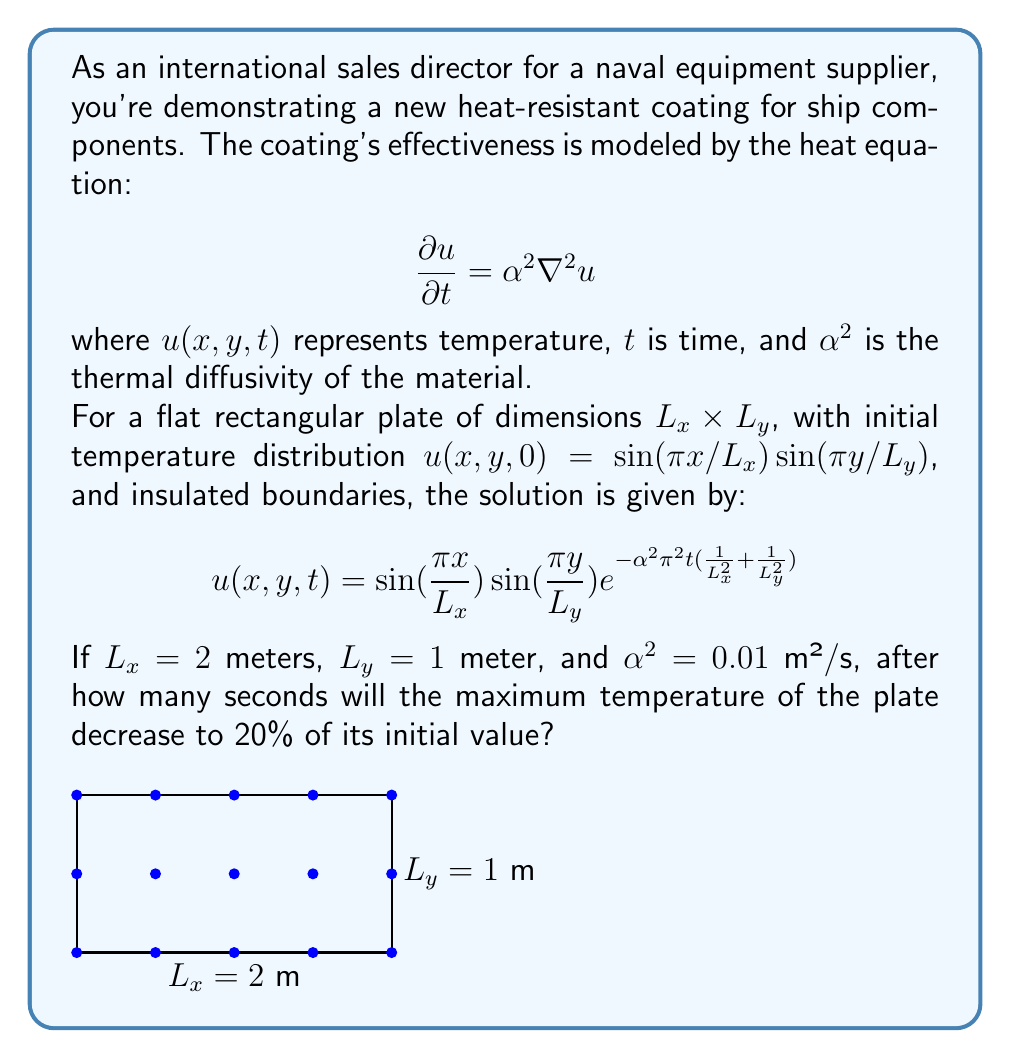Give your solution to this math problem. Let's approach this step-by-step:

1) The maximum temperature occurs at the center of the plate $(L_x/2, L_y/2)$ at any given time. We need to find $t$ when:

   $$u(L_x/2, L_y/2, t) = 0.2 \cdot u(L_x/2, L_y/2, 0)$$

2) At $t=0$, the maximum temperature is:
   
   $$u(L_x/2, L_y/2, 0) = \sin(\frac{\pi}{2})\sin(\frac{\pi}{2}) = 1$$

3) So, we need to solve:

   $$\sin(\frac{\pi}{2})\sin(\frac{\pi}{2})e^{-\alpha^2\pi^2t(\frac{1}{L_x^2}+\frac{1}{L_y^2})} = 0.2$$

4) Simplifying:

   $$e^{-\alpha^2\pi^2t(\frac{1}{L_x^2}+\frac{1}{L_y^2})} = 0.2$$

5) Taking natural log of both sides:

   $$-\alpha^2\pi^2t(\frac{1}{L_x^2}+\frac{1}{L_y^2}) = \ln(0.2)$$

6) Solving for $t$:

   $$t = \frac{-\ln(0.2)}{\alpha^2\pi^2(\frac{1}{L_x^2}+\frac{1}{L_y^2})}$$

7) Substituting the given values:

   $$t = \frac{-\ln(0.2)}{0.01\pi^2(\frac{1}{2^2}+\frac{1}{1^2})} = \frac{1.60944}{0.01\pi^2(0.25+1)}$$

8) Calculating:

   $$t \approx 16.32 \text{ seconds}$$
Answer: 16.32 seconds 